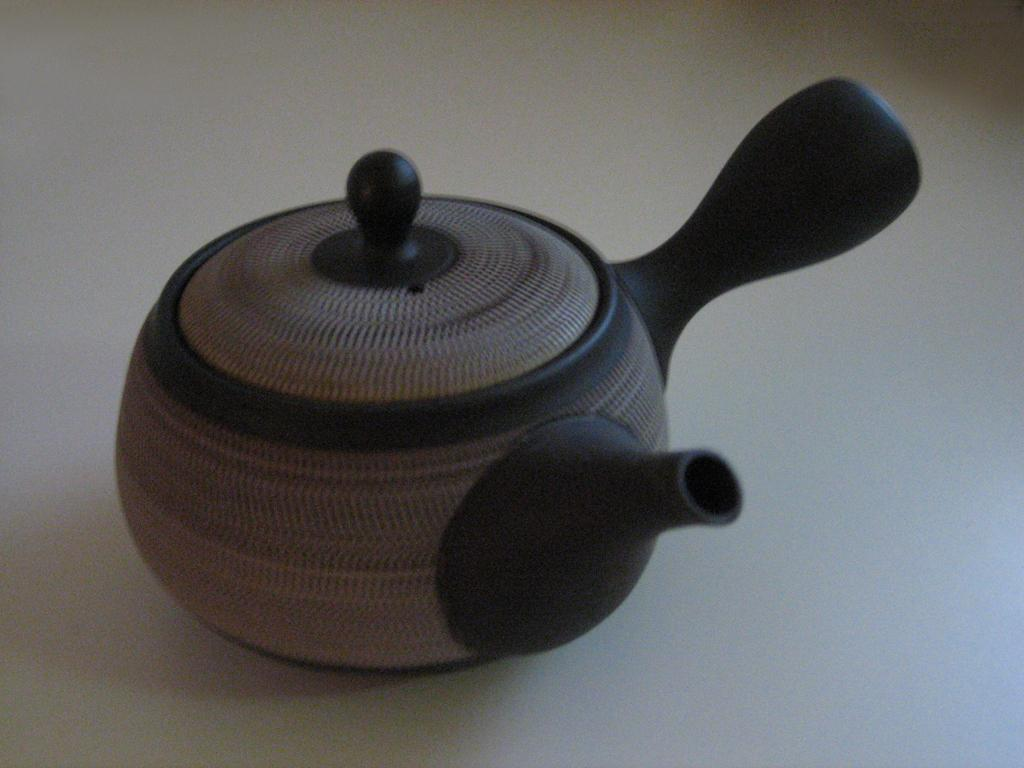What can be seen in the image? There is an object in the image. Can you describe the object's location? The object is on a surface. Who is the creator of the tax in the image? There is no tax or creator mentioned in the image. 